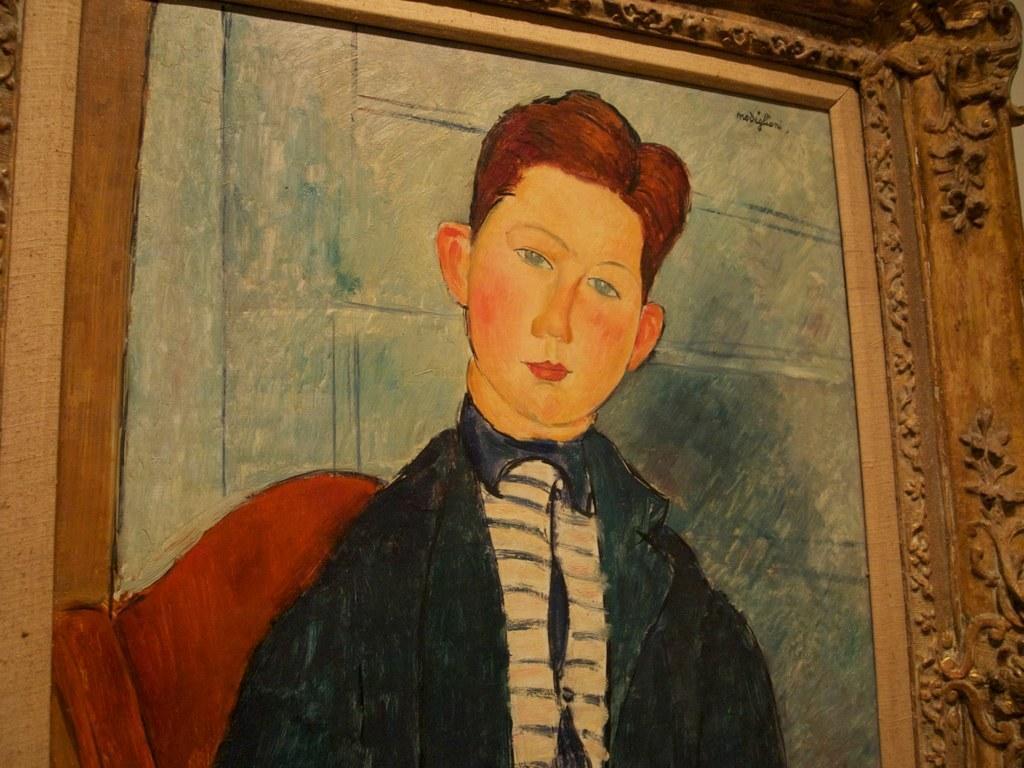Describe this image in one or two sentences. In this image we can see a photo frame. In the frame we can see a painting of a person. 